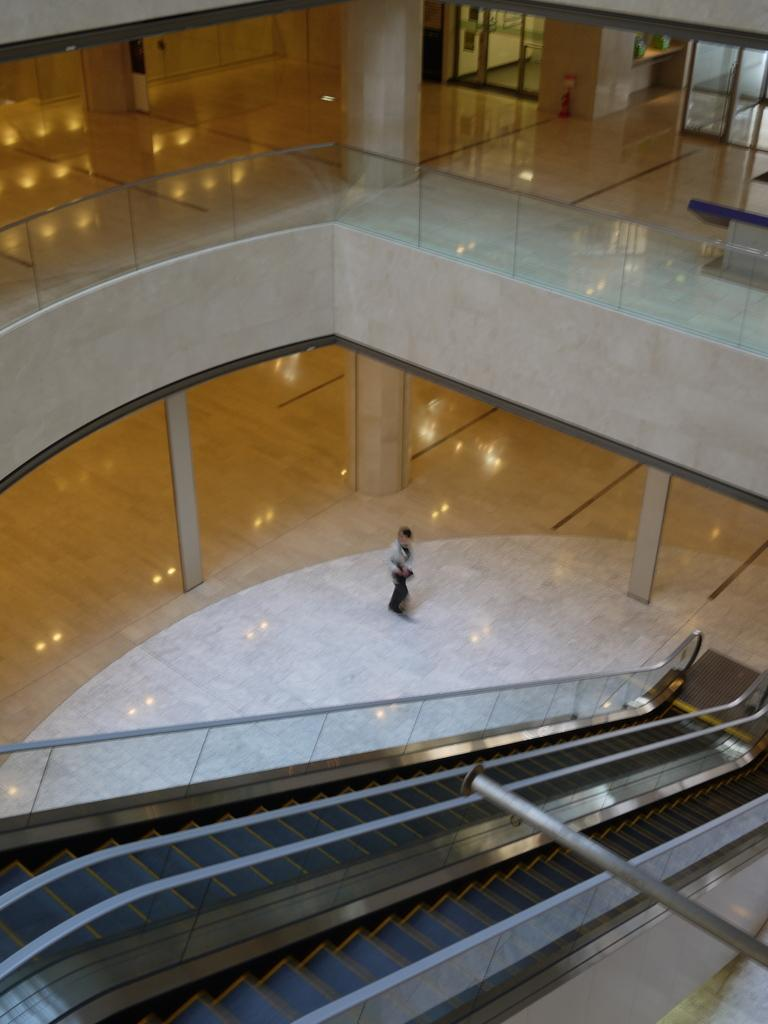What part of a building can be seen in the image? The image shows the inner part of a building. What architectural feature is visible in the image? There are stairs visible in the image. Are there any people present in the image? Yes, there is a person standing in the image. What type of cork can be seen on the person's head in the image? There is no cork present on the person's head in the image. How does the person's anger affect the aftermath of the situation in the image? There is no indication of anger or an aftermath in the image; it simply shows a person standing near stairs in a building. 